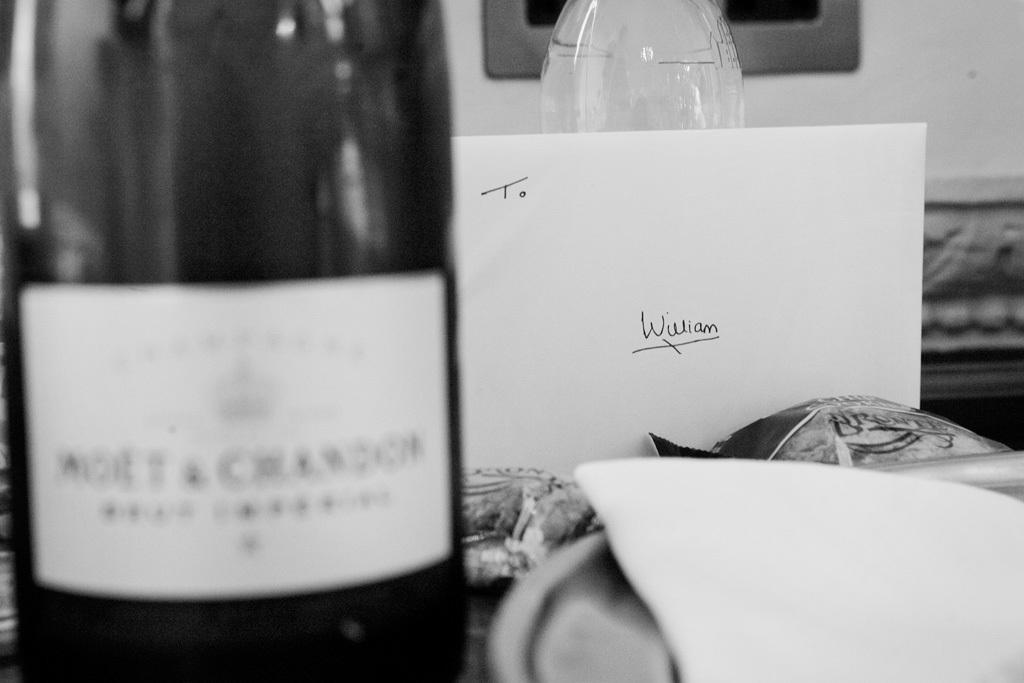What is the main object in the image? There is a wine bottle in the image. What other item can be seen in the image? There is a card with text in the image. How would you describe the color scheme of the image? The image is in black and white. What type of curtain is hanging in the background of the image? There is no curtain present in the image; it is a black and white image featuring a wine bottle and a card with text. 